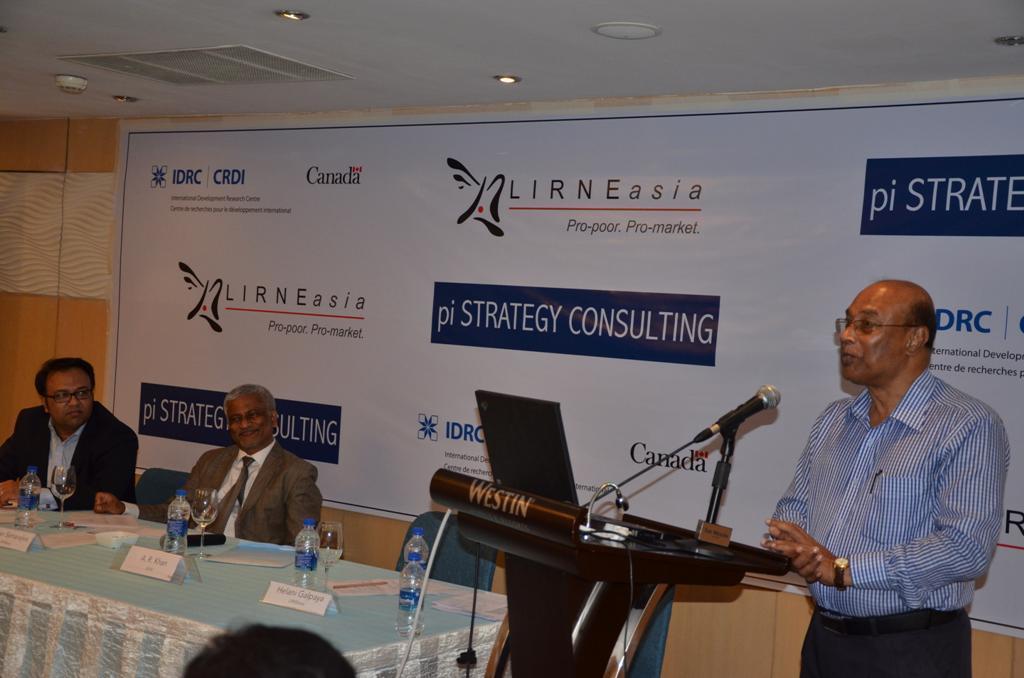How would you summarize this image in a sentence or two? In this image we can see the person standing and in front of the podium and we can see the microphone and a laptop on the podium. And at the side, we can see there are a few people sitting on the chair near the table, on the table there are bottles, glasses, boards with text and a few objects. And at the back we can see the banner with text and logo attached to the wall. At the top we can see the ceiling with lights. 